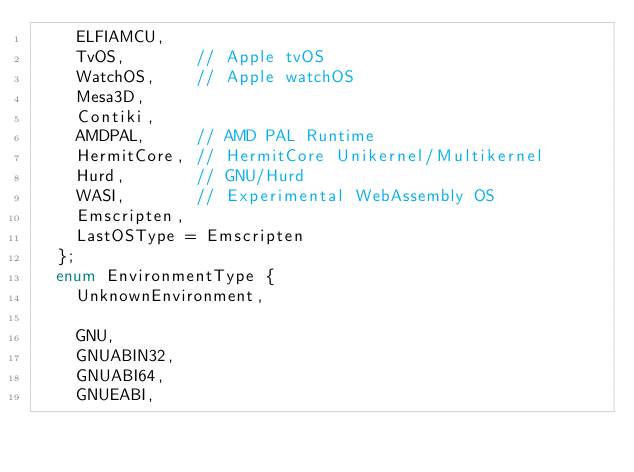<code> <loc_0><loc_0><loc_500><loc_500><_C_>    ELFIAMCU,
    TvOS,       // Apple tvOS
    WatchOS,    // Apple watchOS
    Mesa3D,
    Contiki,
    AMDPAL,     // AMD PAL Runtime
    HermitCore, // HermitCore Unikernel/Multikernel
    Hurd,       // GNU/Hurd
    WASI,       // Experimental WebAssembly OS
    Emscripten,
    LastOSType = Emscripten
  };
  enum EnvironmentType {
    UnknownEnvironment,

    GNU,
    GNUABIN32,
    GNUABI64,
    GNUEABI,</code> 